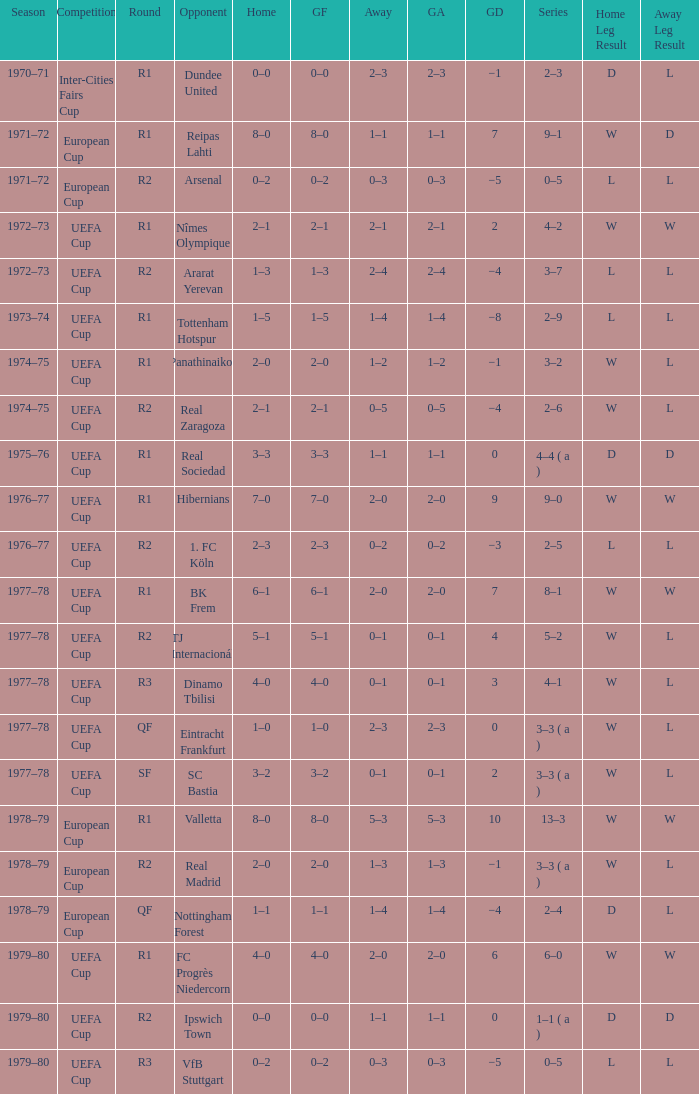Which Home has a Round of r1, and an Opponent of dundee united? 0–0. 